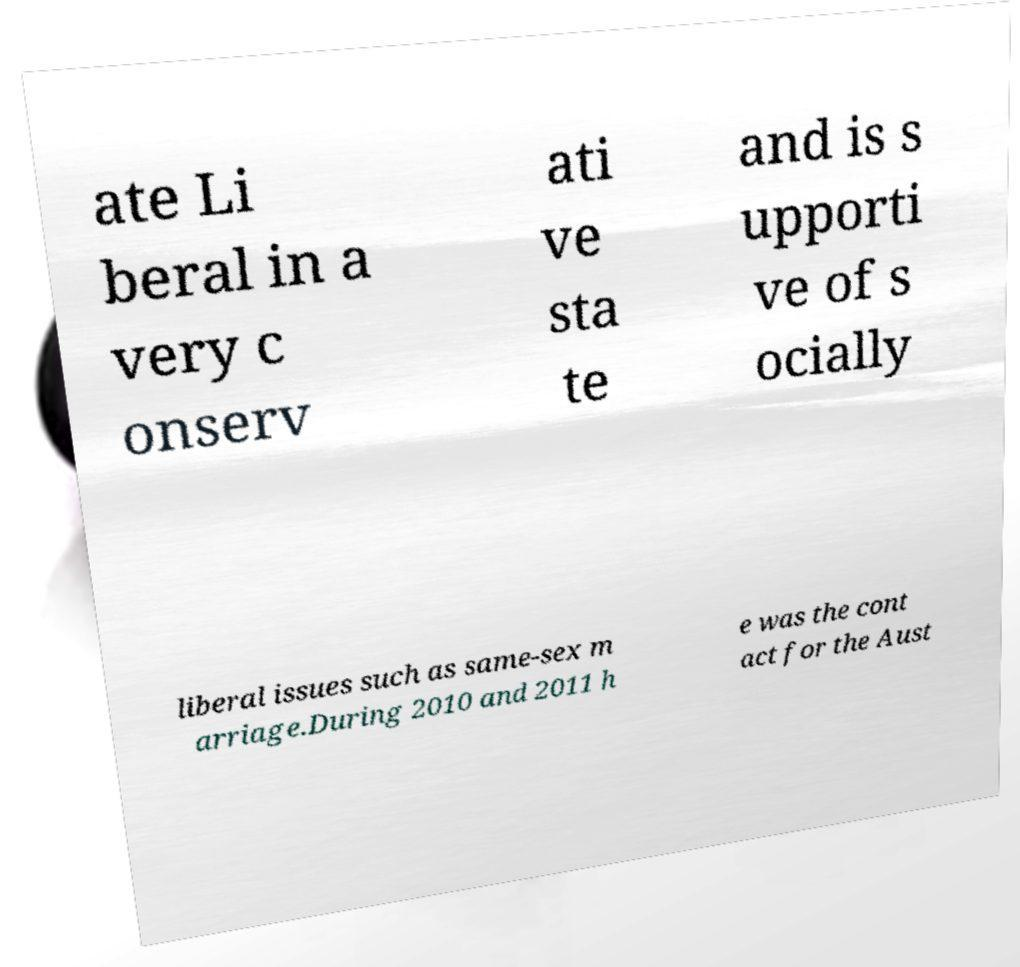Can you read and provide the text displayed in the image?This photo seems to have some interesting text. Can you extract and type it out for me? ate Li beral in a very c onserv ati ve sta te and is s upporti ve of s ocially liberal issues such as same-sex m arriage.During 2010 and 2011 h e was the cont act for the Aust 